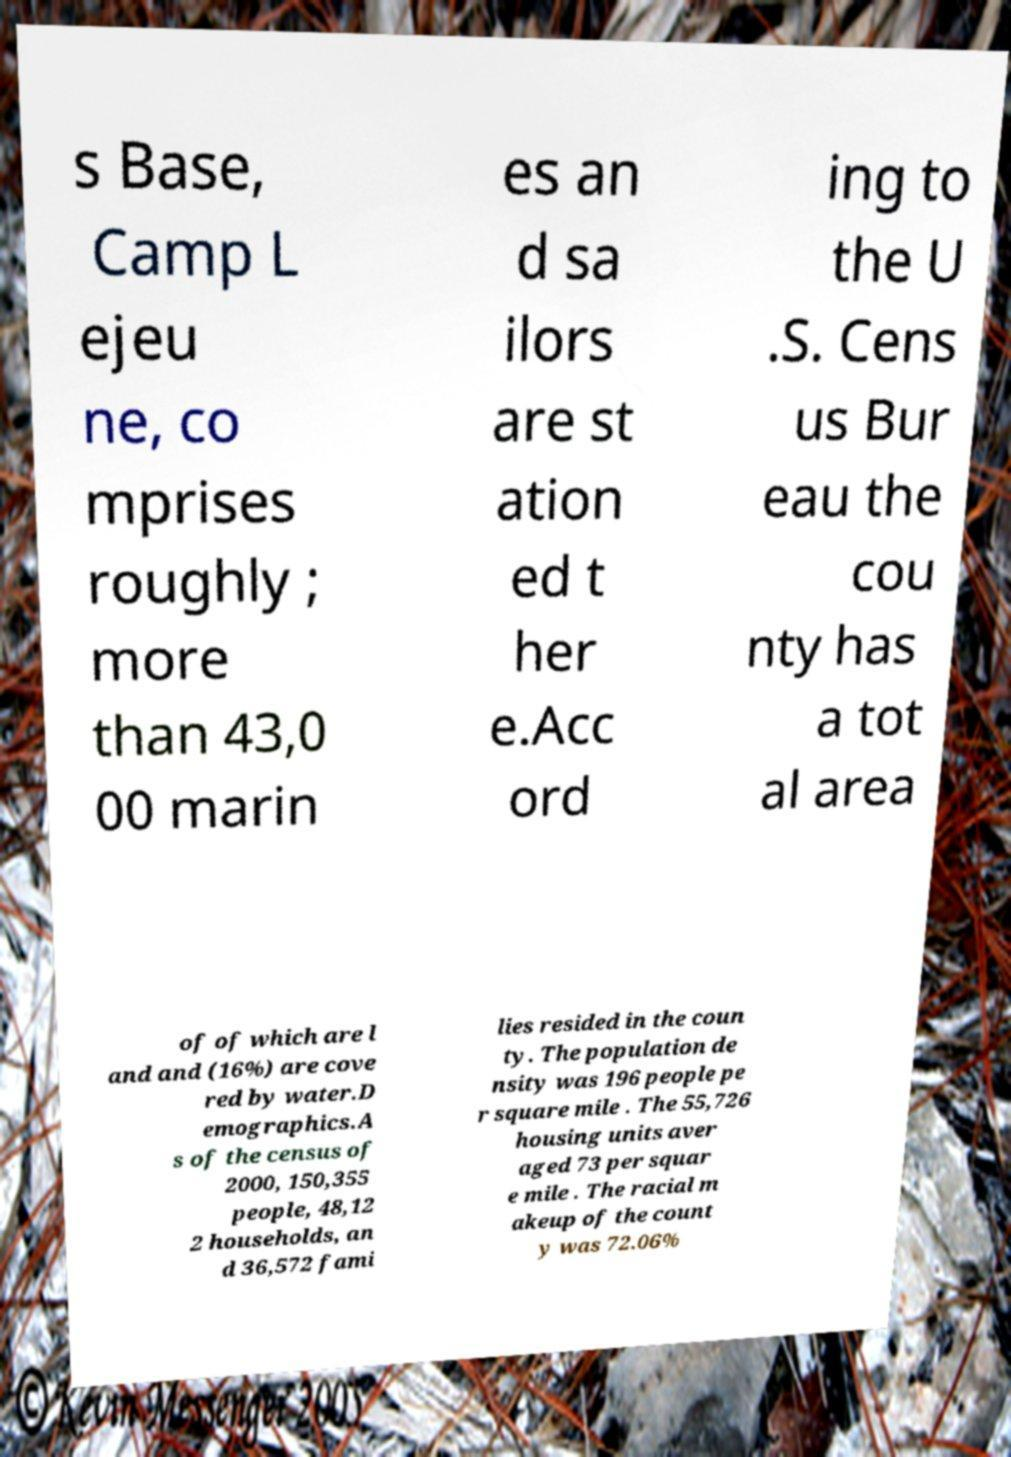What messages or text are displayed in this image? I need them in a readable, typed format. s Base, Camp L ejeu ne, co mprises roughly ; more than 43,0 00 marin es an d sa ilors are st ation ed t her e.Acc ord ing to the U .S. Cens us Bur eau the cou nty has a tot al area of of which are l and and (16%) are cove red by water.D emographics.A s of the census of 2000, 150,355 people, 48,12 2 households, an d 36,572 fami lies resided in the coun ty. The population de nsity was 196 people pe r square mile . The 55,726 housing units aver aged 73 per squar e mile . The racial m akeup of the count y was 72.06% 